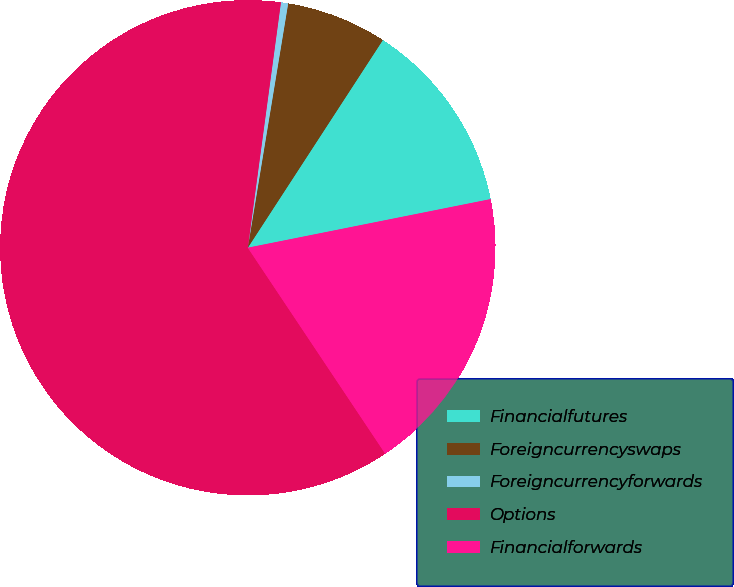<chart> <loc_0><loc_0><loc_500><loc_500><pie_chart><fcel>Financialfutures<fcel>Foreigncurrencyswaps<fcel>Foreigncurrencyforwards<fcel>Options<fcel>Financialforwards<nl><fcel>12.68%<fcel>6.57%<fcel>0.47%<fcel>61.5%<fcel>18.78%<nl></chart> 